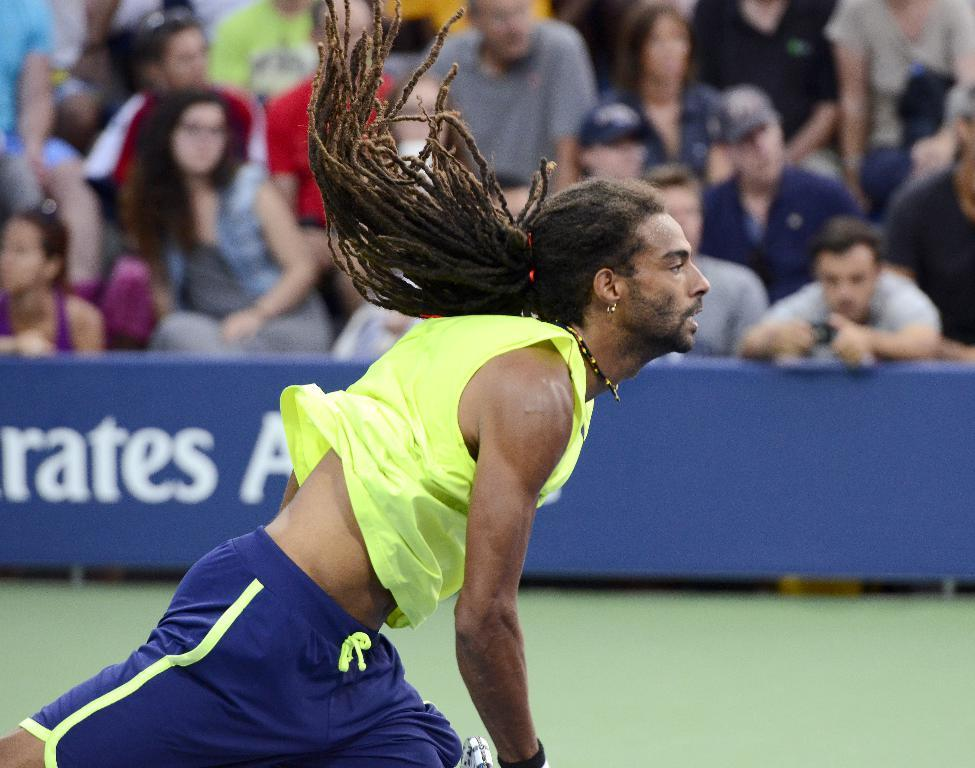What is the person in the image doing? There is a person running on the grassland in the image. What can be seen in the background of the image? There is a banner with text in the image, and people are visible at the top of the image. What is the person on the right side of the image holding? There is a person holding an object on the right side of the image. What time of day is it in the image? The provided facts do not mention the time of day, so it cannot be determined from the image. 